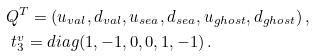Convert formula to latex. <formula><loc_0><loc_0><loc_500><loc_500>& Q ^ { T } = ( u _ { v a l } , d _ { v a l } , u _ { s e a } , d _ { s e a } , u _ { g h o s t } , d _ { g h o s t } ) \, , & \\ & \ t _ { 3 } ^ { v } = d i a g ( 1 , - 1 , 0 , 0 , 1 , - 1 ) \, . &</formula> 